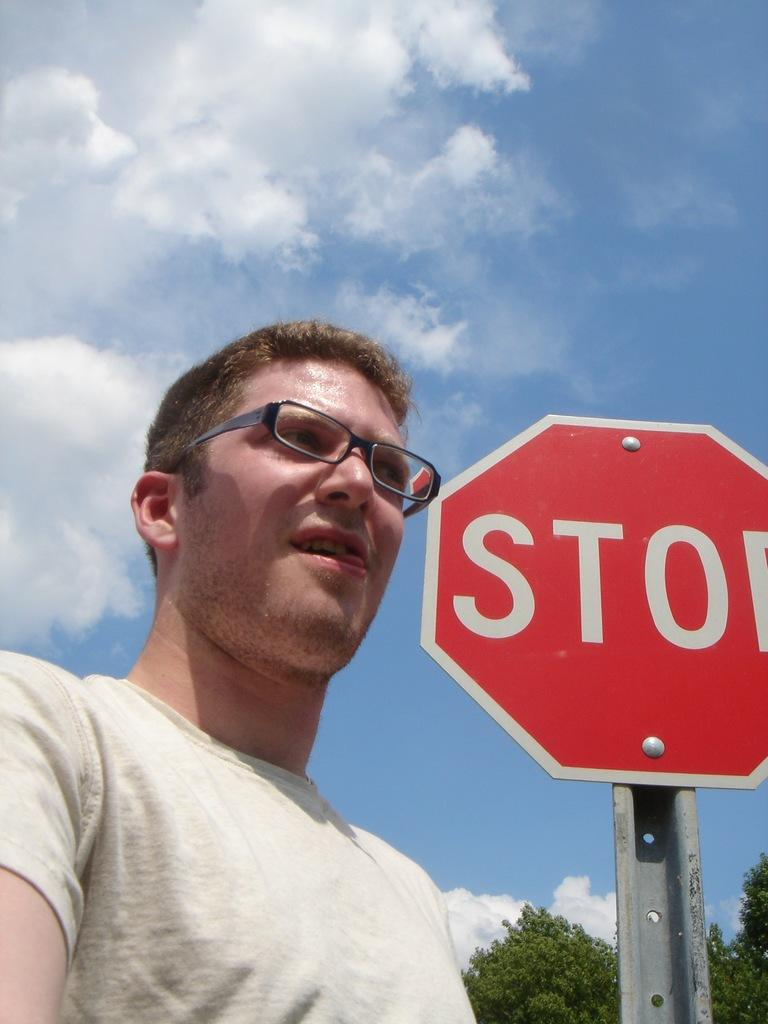<image>
Relay a brief, clear account of the picture shown. a stop sign that is next to a man with glasses 